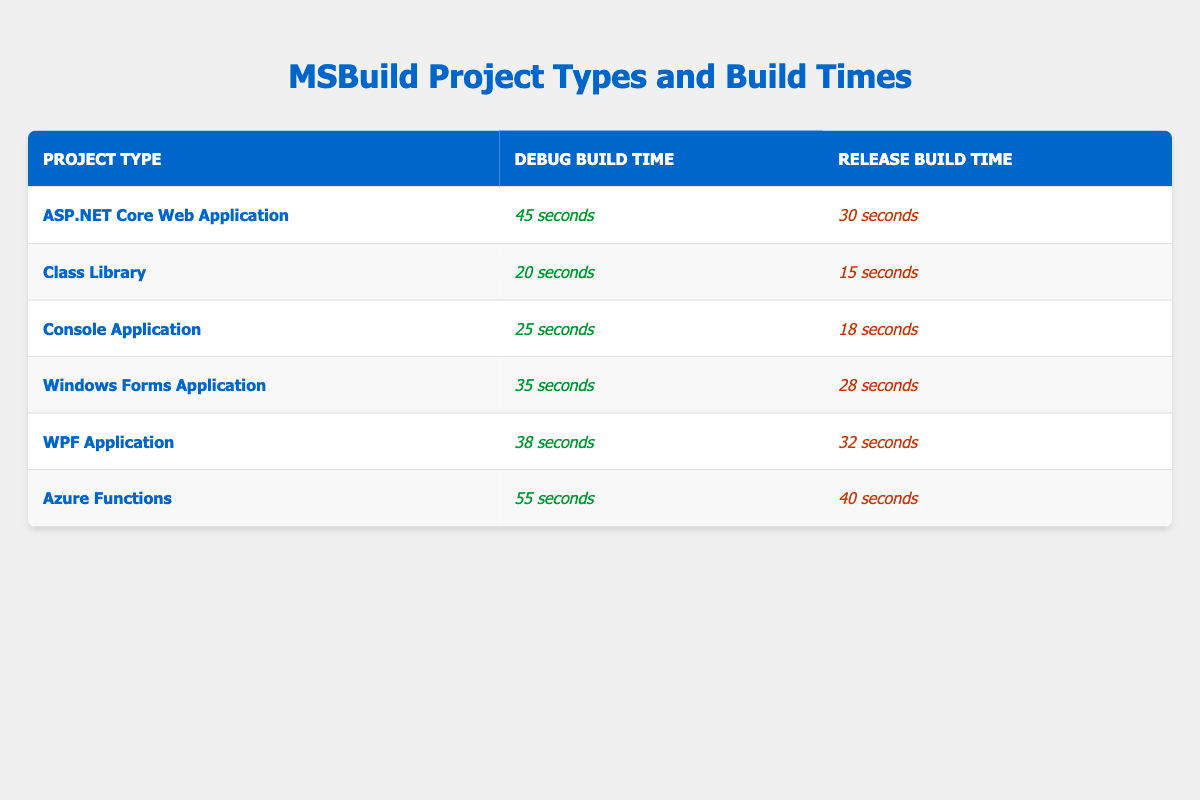What is the build time for a Class Library in Debug configuration? The table lists the build time for a Class Library under the Debug configuration as 20 seconds.
Answer: 20 seconds What is the build time for an ASP.NET Core Web Application in Release configuration? According to the table, the build time for an ASP.NET Core Web Application in the Release configuration is 30 seconds.
Answer: 30 seconds Which project type has the longest build time when in Debug configuration? The build times for Debug configuration are: ASP.NET Core Web Application (45 seconds), Class Library (20 seconds), Console Application (25 seconds), Windows Forms Application (35 seconds), WPF Application (38 seconds), and Azure Functions (55 seconds). The longest time is for Azure Functions at 55 seconds.
Answer: Azure Functions What is the difference in build time between the Debug and Release configurations for a Console Application? The table shows the Debug build time for a Console Application as 25 seconds and the Release build time as 18 seconds. The difference is 25 seconds - 18 seconds = 7 seconds.
Answer: 7 seconds Is the Debug build time for a WPF Application greater than that for a Windows Forms Application? The Debug build time for WPF Application is 38 seconds, while for Windows Forms Application it is 35 seconds. Since 38 seconds is greater than 35 seconds, the statement is true.
Answer: Yes What is the average build time for all project types in their Release configurations? The Release build times are: 30 (ASP.NET Core) + 15 (Class Library) + 18 (Console Application) + 28 (Windows Forms) + 32 (WPF) + 40 (Azure Functions) = 163 seconds. There are 6 project types, so the average is 163 seconds / 6 ≈ 27.17 seconds.
Answer: Approximately 27.17 seconds Which project type has the second longest build time in Debug configuration? The Debug build times listed are: ASP.NET Core Web Application (45 seconds), Azure Functions (55 seconds), Windows Forms Application (35 seconds), WPF Application (38 seconds), Console Application (25 seconds), and Class Library (20 seconds). After Azure Functions, the second longest is ASP.NET Core Web Application at 45 seconds.
Answer: ASP.NET Core Web Application What is the least time-consuming MSBuild project type in the Release configuration? The Release build times in the table are: ASP.NET Core Web Application (30 seconds), Class Library (15 seconds), Console Application (18 seconds), Windows Forms Application (28 seconds), WPF Application (32 seconds), and Azure Functions (40 seconds). Class Library has the least time at 15 seconds.
Answer: Class Library 